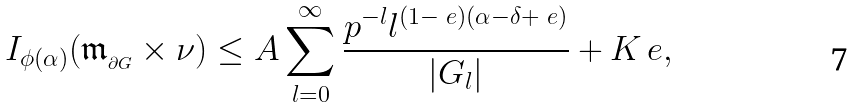<formula> <loc_0><loc_0><loc_500><loc_500>I _ { \phi ( \alpha ) } ( \mathfrak { m } _ { _ { \partial G } } \times \nu ) \leq A \sum _ { l = 0 } ^ { \infty } \frac { p ^ { - l } l ^ { ( 1 - \ e ) ( \alpha - \delta + \ e ) } } { | G _ { l } | } + K _ { \ } e ,</formula> 